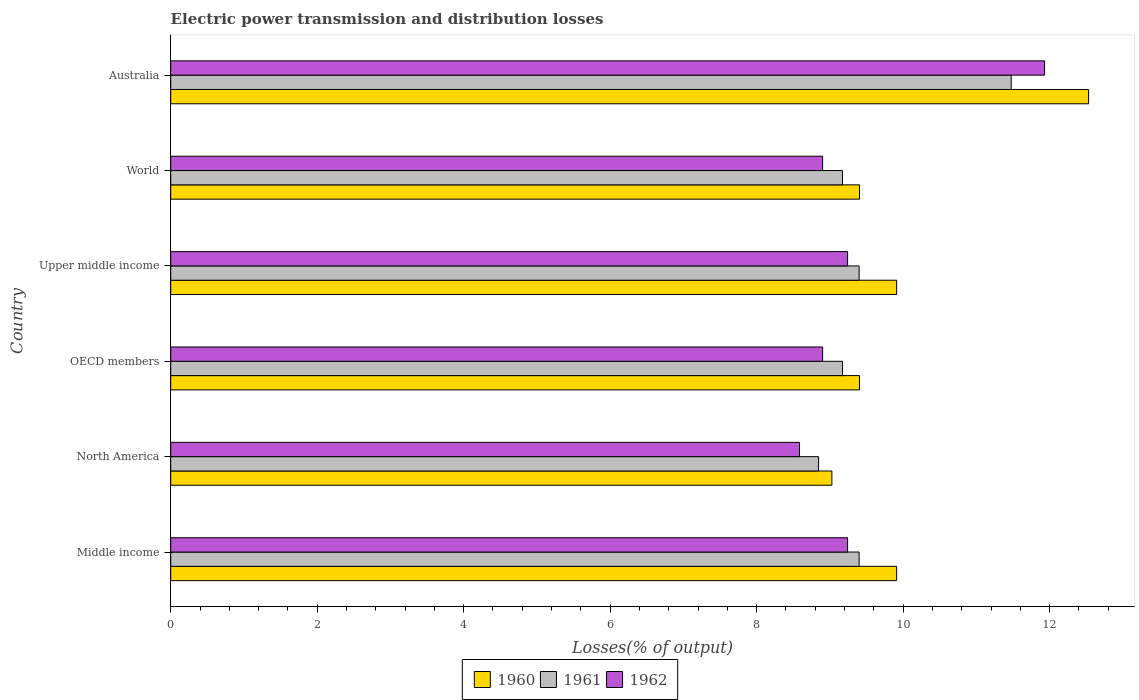How many groups of bars are there?
Make the answer very short. 6. Are the number of bars on each tick of the Y-axis equal?
Keep it short and to the point. Yes. How many bars are there on the 6th tick from the top?
Your response must be concise. 3. How many bars are there on the 3rd tick from the bottom?
Keep it short and to the point. 3. What is the label of the 2nd group of bars from the top?
Offer a very short reply. World. In how many cases, is the number of bars for a given country not equal to the number of legend labels?
Give a very brief answer. 0. What is the electric power transmission and distribution losses in 1961 in Middle income?
Provide a succinct answer. 9.4. Across all countries, what is the maximum electric power transmission and distribution losses in 1960?
Keep it short and to the point. 12.53. Across all countries, what is the minimum electric power transmission and distribution losses in 1960?
Make the answer very short. 9.03. In which country was the electric power transmission and distribution losses in 1962 maximum?
Your answer should be compact. Australia. In which country was the electric power transmission and distribution losses in 1960 minimum?
Make the answer very short. North America. What is the total electric power transmission and distribution losses in 1962 in the graph?
Your answer should be very brief. 56.8. What is the difference between the electric power transmission and distribution losses in 1960 in Australia and that in Upper middle income?
Make the answer very short. 2.62. What is the difference between the electric power transmission and distribution losses in 1962 in Middle income and the electric power transmission and distribution losses in 1961 in World?
Provide a succinct answer. 0.07. What is the average electric power transmission and distribution losses in 1962 per country?
Keep it short and to the point. 9.47. What is the difference between the electric power transmission and distribution losses in 1961 and electric power transmission and distribution losses in 1960 in OECD members?
Keep it short and to the point. -0.23. In how many countries, is the electric power transmission and distribution losses in 1962 greater than 2.4 %?
Provide a succinct answer. 6. What is the difference between the highest and the second highest electric power transmission and distribution losses in 1960?
Your response must be concise. 2.62. What is the difference between the highest and the lowest electric power transmission and distribution losses in 1962?
Offer a very short reply. 3.35. Is the sum of the electric power transmission and distribution losses in 1962 in Middle income and World greater than the maximum electric power transmission and distribution losses in 1961 across all countries?
Keep it short and to the point. Yes. How many countries are there in the graph?
Your answer should be compact. 6. Are the values on the major ticks of X-axis written in scientific E-notation?
Your answer should be compact. No. Does the graph contain any zero values?
Provide a short and direct response. No. Does the graph contain grids?
Ensure brevity in your answer.  No. How many legend labels are there?
Offer a very short reply. 3. What is the title of the graph?
Your answer should be very brief. Electric power transmission and distribution losses. Does "1989" appear as one of the legend labels in the graph?
Give a very brief answer. No. What is the label or title of the X-axis?
Ensure brevity in your answer.  Losses(% of output). What is the Losses(% of output) in 1960 in Middle income?
Make the answer very short. 9.91. What is the Losses(% of output) of 1961 in Middle income?
Offer a very short reply. 9.4. What is the Losses(% of output) of 1962 in Middle income?
Make the answer very short. 9.24. What is the Losses(% of output) in 1960 in North America?
Ensure brevity in your answer.  9.03. What is the Losses(% of output) in 1961 in North America?
Your answer should be very brief. 8.85. What is the Losses(% of output) of 1962 in North America?
Keep it short and to the point. 8.59. What is the Losses(% of output) of 1960 in OECD members?
Keep it short and to the point. 9.4. What is the Losses(% of output) of 1961 in OECD members?
Ensure brevity in your answer.  9.17. What is the Losses(% of output) of 1962 in OECD members?
Provide a short and direct response. 8.9. What is the Losses(% of output) in 1960 in Upper middle income?
Make the answer very short. 9.91. What is the Losses(% of output) in 1961 in Upper middle income?
Offer a terse response. 9.4. What is the Losses(% of output) of 1962 in Upper middle income?
Offer a terse response. 9.24. What is the Losses(% of output) of 1960 in World?
Your answer should be very brief. 9.4. What is the Losses(% of output) of 1961 in World?
Offer a terse response. 9.17. What is the Losses(% of output) of 1962 in World?
Your response must be concise. 8.9. What is the Losses(% of output) in 1960 in Australia?
Your answer should be compact. 12.53. What is the Losses(% of output) in 1961 in Australia?
Ensure brevity in your answer.  11.48. What is the Losses(% of output) in 1962 in Australia?
Ensure brevity in your answer.  11.93. Across all countries, what is the maximum Losses(% of output) in 1960?
Offer a very short reply. 12.53. Across all countries, what is the maximum Losses(% of output) in 1961?
Your answer should be compact. 11.48. Across all countries, what is the maximum Losses(% of output) of 1962?
Provide a short and direct response. 11.93. Across all countries, what is the minimum Losses(% of output) of 1960?
Offer a terse response. 9.03. Across all countries, what is the minimum Losses(% of output) of 1961?
Make the answer very short. 8.85. Across all countries, what is the minimum Losses(% of output) in 1962?
Offer a very short reply. 8.59. What is the total Losses(% of output) of 1960 in the graph?
Offer a very short reply. 60.19. What is the total Losses(% of output) of 1961 in the graph?
Offer a very short reply. 57.46. What is the total Losses(% of output) in 1962 in the graph?
Ensure brevity in your answer.  56.8. What is the difference between the Losses(% of output) in 1960 in Middle income and that in North America?
Offer a very short reply. 0.88. What is the difference between the Losses(% of output) in 1961 in Middle income and that in North America?
Offer a terse response. 0.55. What is the difference between the Losses(% of output) in 1962 in Middle income and that in North America?
Your answer should be compact. 0.66. What is the difference between the Losses(% of output) in 1960 in Middle income and that in OECD members?
Your answer should be compact. 0.51. What is the difference between the Losses(% of output) of 1961 in Middle income and that in OECD members?
Give a very brief answer. 0.23. What is the difference between the Losses(% of output) in 1962 in Middle income and that in OECD members?
Make the answer very short. 0.34. What is the difference between the Losses(% of output) in 1960 in Middle income and that in Upper middle income?
Offer a very short reply. 0. What is the difference between the Losses(% of output) of 1961 in Middle income and that in Upper middle income?
Your answer should be compact. 0. What is the difference between the Losses(% of output) in 1960 in Middle income and that in World?
Your answer should be very brief. 0.51. What is the difference between the Losses(% of output) of 1961 in Middle income and that in World?
Offer a very short reply. 0.23. What is the difference between the Losses(% of output) in 1962 in Middle income and that in World?
Keep it short and to the point. 0.34. What is the difference between the Losses(% of output) of 1960 in Middle income and that in Australia?
Provide a succinct answer. -2.62. What is the difference between the Losses(% of output) in 1961 in Middle income and that in Australia?
Give a very brief answer. -2.08. What is the difference between the Losses(% of output) of 1962 in Middle income and that in Australia?
Give a very brief answer. -2.69. What is the difference between the Losses(% of output) of 1960 in North America and that in OECD members?
Make the answer very short. -0.38. What is the difference between the Losses(% of output) in 1961 in North America and that in OECD members?
Keep it short and to the point. -0.33. What is the difference between the Losses(% of output) of 1962 in North America and that in OECD members?
Provide a short and direct response. -0.32. What is the difference between the Losses(% of output) in 1960 in North America and that in Upper middle income?
Offer a terse response. -0.88. What is the difference between the Losses(% of output) of 1961 in North America and that in Upper middle income?
Your answer should be compact. -0.55. What is the difference between the Losses(% of output) in 1962 in North America and that in Upper middle income?
Provide a short and direct response. -0.66. What is the difference between the Losses(% of output) in 1960 in North America and that in World?
Your answer should be very brief. -0.38. What is the difference between the Losses(% of output) in 1961 in North America and that in World?
Ensure brevity in your answer.  -0.33. What is the difference between the Losses(% of output) of 1962 in North America and that in World?
Ensure brevity in your answer.  -0.32. What is the difference between the Losses(% of output) in 1960 in North America and that in Australia?
Your response must be concise. -3.5. What is the difference between the Losses(% of output) in 1961 in North America and that in Australia?
Offer a terse response. -2.63. What is the difference between the Losses(% of output) in 1962 in North America and that in Australia?
Keep it short and to the point. -3.35. What is the difference between the Losses(% of output) of 1960 in OECD members and that in Upper middle income?
Ensure brevity in your answer.  -0.51. What is the difference between the Losses(% of output) in 1961 in OECD members and that in Upper middle income?
Keep it short and to the point. -0.23. What is the difference between the Losses(% of output) of 1962 in OECD members and that in Upper middle income?
Your answer should be compact. -0.34. What is the difference between the Losses(% of output) in 1962 in OECD members and that in World?
Provide a short and direct response. 0. What is the difference between the Losses(% of output) in 1960 in OECD members and that in Australia?
Your response must be concise. -3.13. What is the difference between the Losses(% of output) in 1961 in OECD members and that in Australia?
Ensure brevity in your answer.  -2.3. What is the difference between the Losses(% of output) in 1962 in OECD members and that in Australia?
Make the answer very short. -3.03. What is the difference between the Losses(% of output) of 1960 in Upper middle income and that in World?
Provide a succinct answer. 0.51. What is the difference between the Losses(% of output) of 1961 in Upper middle income and that in World?
Your answer should be compact. 0.23. What is the difference between the Losses(% of output) of 1962 in Upper middle income and that in World?
Offer a very short reply. 0.34. What is the difference between the Losses(% of output) in 1960 in Upper middle income and that in Australia?
Offer a very short reply. -2.62. What is the difference between the Losses(% of output) of 1961 in Upper middle income and that in Australia?
Offer a very short reply. -2.08. What is the difference between the Losses(% of output) of 1962 in Upper middle income and that in Australia?
Provide a succinct answer. -2.69. What is the difference between the Losses(% of output) of 1960 in World and that in Australia?
Your answer should be very brief. -3.13. What is the difference between the Losses(% of output) of 1961 in World and that in Australia?
Ensure brevity in your answer.  -2.3. What is the difference between the Losses(% of output) of 1962 in World and that in Australia?
Offer a very short reply. -3.03. What is the difference between the Losses(% of output) of 1960 in Middle income and the Losses(% of output) of 1961 in North America?
Your answer should be very brief. 1.07. What is the difference between the Losses(% of output) in 1960 in Middle income and the Losses(% of output) in 1962 in North America?
Provide a short and direct response. 1.33. What is the difference between the Losses(% of output) in 1961 in Middle income and the Losses(% of output) in 1962 in North America?
Offer a very short reply. 0.81. What is the difference between the Losses(% of output) in 1960 in Middle income and the Losses(% of output) in 1961 in OECD members?
Your answer should be very brief. 0.74. What is the difference between the Losses(% of output) in 1960 in Middle income and the Losses(% of output) in 1962 in OECD members?
Offer a very short reply. 1.01. What is the difference between the Losses(% of output) in 1961 in Middle income and the Losses(% of output) in 1962 in OECD members?
Ensure brevity in your answer.  0.5. What is the difference between the Losses(% of output) of 1960 in Middle income and the Losses(% of output) of 1961 in Upper middle income?
Offer a very short reply. 0.51. What is the difference between the Losses(% of output) in 1960 in Middle income and the Losses(% of output) in 1962 in Upper middle income?
Ensure brevity in your answer.  0.67. What is the difference between the Losses(% of output) in 1961 in Middle income and the Losses(% of output) in 1962 in Upper middle income?
Make the answer very short. 0.16. What is the difference between the Losses(% of output) in 1960 in Middle income and the Losses(% of output) in 1961 in World?
Give a very brief answer. 0.74. What is the difference between the Losses(% of output) in 1960 in Middle income and the Losses(% of output) in 1962 in World?
Make the answer very short. 1.01. What is the difference between the Losses(% of output) in 1961 in Middle income and the Losses(% of output) in 1962 in World?
Your answer should be very brief. 0.5. What is the difference between the Losses(% of output) of 1960 in Middle income and the Losses(% of output) of 1961 in Australia?
Keep it short and to the point. -1.56. What is the difference between the Losses(% of output) in 1960 in Middle income and the Losses(% of output) in 1962 in Australia?
Your response must be concise. -2.02. What is the difference between the Losses(% of output) of 1961 in Middle income and the Losses(% of output) of 1962 in Australia?
Offer a very short reply. -2.53. What is the difference between the Losses(% of output) in 1960 in North America and the Losses(% of output) in 1961 in OECD members?
Ensure brevity in your answer.  -0.14. What is the difference between the Losses(% of output) of 1960 in North America and the Losses(% of output) of 1962 in OECD members?
Offer a terse response. 0.13. What is the difference between the Losses(% of output) of 1961 in North America and the Losses(% of output) of 1962 in OECD members?
Your response must be concise. -0.06. What is the difference between the Losses(% of output) of 1960 in North America and the Losses(% of output) of 1961 in Upper middle income?
Provide a short and direct response. -0.37. What is the difference between the Losses(% of output) in 1960 in North America and the Losses(% of output) in 1962 in Upper middle income?
Give a very brief answer. -0.21. What is the difference between the Losses(% of output) of 1961 in North America and the Losses(% of output) of 1962 in Upper middle income?
Offer a very short reply. -0.4. What is the difference between the Losses(% of output) in 1960 in North America and the Losses(% of output) in 1961 in World?
Your answer should be very brief. -0.14. What is the difference between the Losses(% of output) of 1960 in North America and the Losses(% of output) of 1962 in World?
Your answer should be very brief. 0.13. What is the difference between the Losses(% of output) of 1961 in North America and the Losses(% of output) of 1962 in World?
Offer a very short reply. -0.06. What is the difference between the Losses(% of output) of 1960 in North America and the Losses(% of output) of 1961 in Australia?
Your answer should be very brief. -2.45. What is the difference between the Losses(% of output) of 1960 in North America and the Losses(% of output) of 1962 in Australia?
Provide a succinct answer. -2.9. What is the difference between the Losses(% of output) in 1961 in North America and the Losses(% of output) in 1962 in Australia?
Make the answer very short. -3.09. What is the difference between the Losses(% of output) in 1960 in OECD members and the Losses(% of output) in 1961 in Upper middle income?
Keep it short and to the point. 0.01. What is the difference between the Losses(% of output) of 1960 in OECD members and the Losses(% of output) of 1962 in Upper middle income?
Offer a very short reply. 0.16. What is the difference between the Losses(% of output) of 1961 in OECD members and the Losses(% of output) of 1962 in Upper middle income?
Your answer should be compact. -0.07. What is the difference between the Losses(% of output) of 1960 in OECD members and the Losses(% of output) of 1961 in World?
Keep it short and to the point. 0.23. What is the difference between the Losses(% of output) of 1960 in OECD members and the Losses(% of output) of 1962 in World?
Offer a terse response. 0.5. What is the difference between the Losses(% of output) in 1961 in OECD members and the Losses(% of output) in 1962 in World?
Ensure brevity in your answer.  0.27. What is the difference between the Losses(% of output) in 1960 in OECD members and the Losses(% of output) in 1961 in Australia?
Keep it short and to the point. -2.07. What is the difference between the Losses(% of output) in 1960 in OECD members and the Losses(% of output) in 1962 in Australia?
Keep it short and to the point. -2.53. What is the difference between the Losses(% of output) of 1961 in OECD members and the Losses(% of output) of 1962 in Australia?
Your response must be concise. -2.76. What is the difference between the Losses(% of output) of 1960 in Upper middle income and the Losses(% of output) of 1961 in World?
Your answer should be compact. 0.74. What is the difference between the Losses(% of output) in 1960 in Upper middle income and the Losses(% of output) in 1962 in World?
Provide a short and direct response. 1.01. What is the difference between the Losses(% of output) in 1961 in Upper middle income and the Losses(% of output) in 1962 in World?
Keep it short and to the point. 0.5. What is the difference between the Losses(% of output) in 1960 in Upper middle income and the Losses(% of output) in 1961 in Australia?
Keep it short and to the point. -1.56. What is the difference between the Losses(% of output) of 1960 in Upper middle income and the Losses(% of output) of 1962 in Australia?
Ensure brevity in your answer.  -2.02. What is the difference between the Losses(% of output) in 1961 in Upper middle income and the Losses(% of output) in 1962 in Australia?
Your response must be concise. -2.53. What is the difference between the Losses(% of output) of 1960 in World and the Losses(% of output) of 1961 in Australia?
Provide a short and direct response. -2.07. What is the difference between the Losses(% of output) in 1960 in World and the Losses(% of output) in 1962 in Australia?
Keep it short and to the point. -2.53. What is the difference between the Losses(% of output) in 1961 in World and the Losses(% of output) in 1962 in Australia?
Give a very brief answer. -2.76. What is the average Losses(% of output) in 1960 per country?
Make the answer very short. 10.03. What is the average Losses(% of output) of 1961 per country?
Ensure brevity in your answer.  9.58. What is the average Losses(% of output) of 1962 per country?
Your answer should be very brief. 9.47. What is the difference between the Losses(% of output) in 1960 and Losses(% of output) in 1961 in Middle income?
Offer a very short reply. 0.51. What is the difference between the Losses(% of output) of 1960 and Losses(% of output) of 1962 in Middle income?
Ensure brevity in your answer.  0.67. What is the difference between the Losses(% of output) of 1961 and Losses(% of output) of 1962 in Middle income?
Provide a succinct answer. 0.16. What is the difference between the Losses(% of output) of 1960 and Losses(% of output) of 1961 in North America?
Your response must be concise. 0.18. What is the difference between the Losses(% of output) of 1960 and Losses(% of output) of 1962 in North America?
Ensure brevity in your answer.  0.44. What is the difference between the Losses(% of output) in 1961 and Losses(% of output) in 1962 in North America?
Provide a succinct answer. 0.26. What is the difference between the Losses(% of output) in 1960 and Losses(% of output) in 1961 in OECD members?
Keep it short and to the point. 0.23. What is the difference between the Losses(% of output) in 1960 and Losses(% of output) in 1962 in OECD members?
Provide a short and direct response. 0.5. What is the difference between the Losses(% of output) in 1961 and Losses(% of output) in 1962 in OECD members?
Your answer should be very brief. 0.27. What is the difference between the Losses(% of output) in 1960 and Losses(% of output) in 1961 in Upper middle income?
Provide a succinct answer. 0.51. What is the difference between the Losses(% of output) in 1960 and Losses(% of output) in 1962 in Upper middle income?
Offer a terse response. 0.67. What is the difference between the Losses(% of output) of 1961 and Losses(% of output) of 1962 in Upper middle income?
Keep it short and to the point. 0.16. What is the difference between the Losses(% of output) in 1960 and Losses(% of output) in 1961 in World?
Offer a terse response. 0.23. What is the difference between the Losses(% of output) in 1960 and Losses(% of output) in 1962 in World?
Offer a very short reply. 0.5. What is the difference between the Losses(% of output) of 1961 and Losses(% of output) of 1962 in World?
Give a very brief answer. 0.27. What is the difference between the Losses(% of output) in 1960 and Losses(% of output) in 1961 in Australia?
Offer a terse response. 1.06. What is the difference between the Losses(% of output) in 1960 and Losses(% of output) in 1962 in Australia?
Your response must be concise. 0.6. What is the difference between the Losses(% of output) of 1961 and Losses(% of output) of 1962 in Australia?
Keep it short and to the point. -0.46. What is the ratio of the Losses(% of output) in 1960 in Middle income to that in North America?
Offer a terse response. 1.1. What is the ratio of the Losses(% of output) in 1961 in Middle income to that in North America?
Offer a terse response. 1.06. What is the ratio of the Losses(% of output) in 1962 in Middle income to that in North America?
Your response must be concise. 1.08. What is the ratio of the Losses(% of output) in 1960 in Middle income to that in OECD members?
Your answer should be very brief. 1.05. What is the ratio of the Losses(% of output) in 1961 in Middle income to that in OECD members?
Your answer should be very brief. 1.02. What is the ratio of the Losses(% of output) of 1962 in Middle income to that in OECD members?
Give a very brief answer. 1.04. What is the ratio of the Losses(% of output) in 1960 in Middle income to that in Upper middle income?
Your response must be concise. 1. What is the ratio of the Losses(% of output) of 1961 in Middle income to that in Upper middle income?
Offer a terse response. 1. What is the ratio of the Losses(% of output) of 1962 in Middle income to that in Upper middle income?
Your response must be concise. 1. What is the ratio of the Losses(% of output) in 1960 in Middle income to that in World?
Provide a short and direct response. 1.05. What is the ratio of the Losses(% of output) of 1961 in Middle income to that in World?
Give a very brief answer. 1.02. What is the ratio of the Losses(% of output) of 1962 in Middle income to that in World?
Give a very brief answer. 1.04. What is the ratio of the Losses(% of output) in 1960 in Middle income to that in Australia?
Keep it short and to the point. 0.79. What is the ratio of the Losses(% of output) in 1961 in Middle income to that in Australia?
Your response must be concise. 0.82. What is the ratio of the Losses(% of output) of 1962 in Middle income to that in Australia?
Your response must be concise. 0.77. What is the ratio of the Losses(% of output) of 1960 in North America to that in OECD members?
Your response must be concise. 0.96. What is the ratio of the Losses(% of output) in 1961 in North America to that in OECD members?
Provide a succinct answer. 0.96. What is the ratio of the Losses(% of output) of 1962 in North America to that in OECD members?
Offer a terse response. 0.96. What is the ratio of the Losses(% of output) of 1960 in North America to that in Upper middle income?
Provide a short and direct response. 0.91. What is the ratio of the Losses(% of output) of 1961 in North America to that in Upper middle income?
Your answer should be very brief. 0.94. What is the ratio of the Losses(% of output) of 1962 in North America to that in Upper middle income?
Offer a very short reply. 0.93. What is the ratio of the Losses(% of output) in 1960 in North America to that in World?
Your response must be concise. 0.96. What is the ratio of the Losses(% of output) in 1961 in North America to that in World?
Keep it short and to the point. 0.96. What is the ratio of the Losses(% of output) in 1962 in North America to that in World?
Provide a succinct answer. 0.96. What is the ratio of the Losses(% of output) of 1960 in North America to that in Australia?
Provide a succinct answer. 0.72. What is the ratio of the Losses(% of output) in 1961 in North America to that in Australia?
Your answer should be very brief. 0.77. What is the ratio of the Losses(% of output) of 1962 in North America to that in Australia?
Your answer should be compact. 0.72. What is the ratio of the Losses(% of output) of 1960 in OECD members to that in Upper middle income?
Offer a terse response. 0.95. What is the ratio of the Losses(% of output) of 1961 in OECD members to that in Upper middle income?
Offer a very short reply. 0.98. What is the ratio of the Losses(% of output) in 1962 in OECD members to that in Upper middle income?
Ensure brevity in your answer.  0.96. What is the ratio of the Losses(% of output) of 1961 in OECD members to that in World?
Give a very brief answer. 1. What is the ratio of the Losses(% of output) of 1960 in OECD members to that in Australia?
Your answer should be compact. 0.75. What is the ratio of the Losses(% of output) of 1961 in OECD members to that in Australia?
Your answer should be very brief. 0.8. What is the ratio of the Losses(% of output) of 1962 in OECD members to that in Australia?
Ensure brevity in your answer.  0.75. What is the ratio of the Losses(% of output) in 1960 in Upper middle income to that in World?
Make the answer very short. 1.05. What is the ratio of the Losses(% of output) in 1961 in Upper middle income to that in World?
Your response must be concise. 1.02. What is the ratio of the Losses(% of output) in 1962 in Upper middle income to that in World?
Offer a very short reply. 1.04. What is the ratio of the Losses(% of output) of 1960 in Upper middle income to that in Australia?
Offer a very short reply. 0.79. What is the ratio of the Losses(% of output) in 1961 in Upper middle income to that in Australia?
Provide a succinct answer. 0.82. What is the ratio of the Losses(% of output) in 1962 in Upper middle income to that in Australia?
Make the answer very short. 0.77. What is the ratio of the Losses(% of output) of 1960 in World to that in Australia?
Offer a terse response. 0.75. What is the ratio of the Losses(% of output) of 1961 in World to that in Australia?
Provide a short and direct response. 0.8. What is the ratio of the Losses(% of output) of 1962 in World to that in Australia?
Provide a succinct answer. 0.75. What is the difference between the highest and the second highest Losses(% of output) in 1960?
Keep it short and to the point. 2.62. What is the difference between the highest and the second highest Losses(% of output) in 1961?
Offer a very short reply. 2.08. What is the difference between the highest and the second highest Losses(% of output) of 1962?
Provide a short and direct response. 2.69. What is the difference between the highest and the lowest Losses(% of output) in 1960?
Offer a terse response. 3.5. What is the difference between the highest and the lowest Losses(% of output) of 1961?
Your response must be concise. 2.63. What is the difference between the highest and the lowest Losses(% of output) in 1962?
Offer a very short reply. 3.35. 